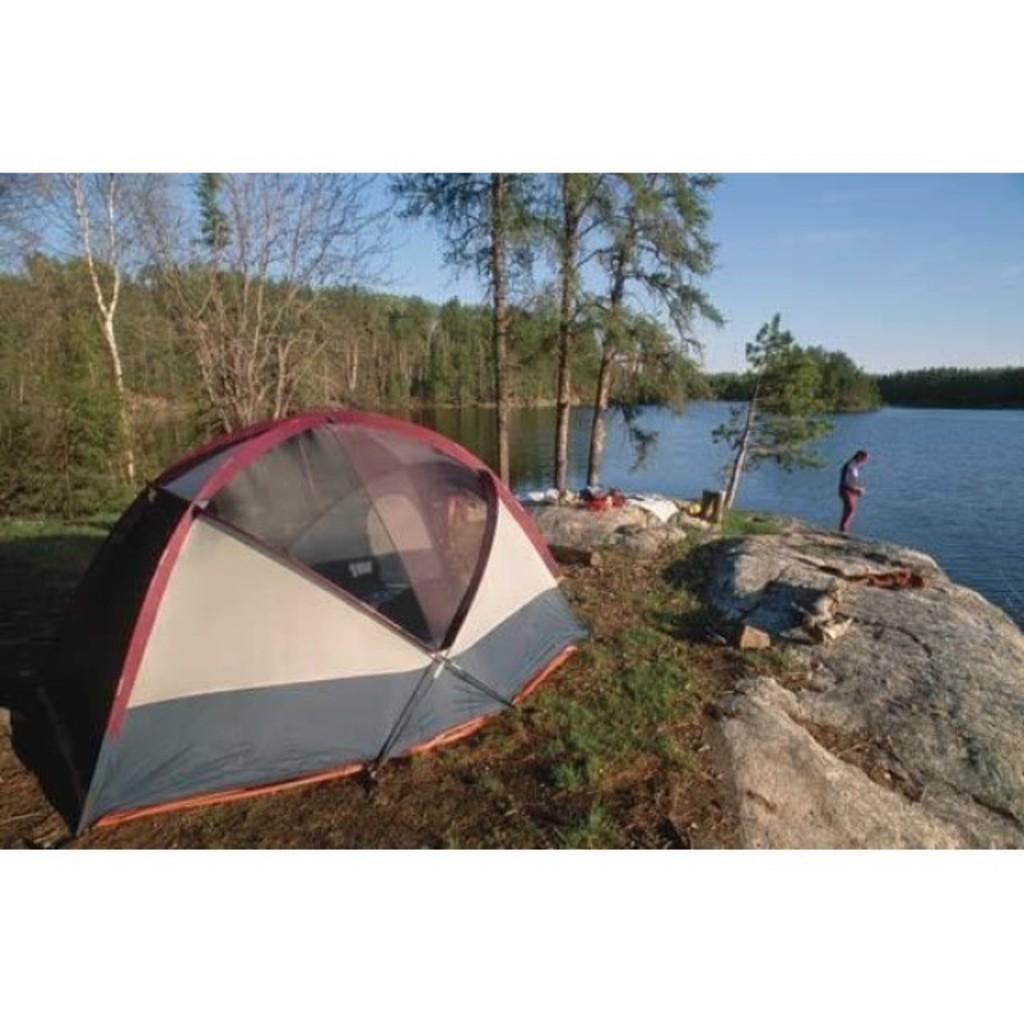What type of shelter is visible in the image? There is a tent in the image. What is the person in the image standing on? The person is standing on rocks in the image. What type of vegetation can be seen in the image? There are trees in the image. What body of water is present in the image? There is a lake in the image. What can be seen in the sky in the image? The sky with clouds is visible in the image. What type of prose is being recited by the trees in the image? There is no indication in the image that the trees are reciting any prose. What kind of net is being used to catch the clouds in the image? There is no net present in the image, and the clouds are not being caught. 